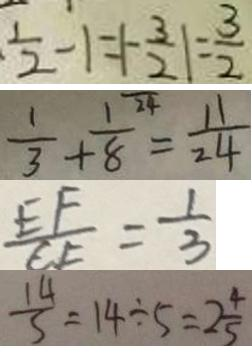Convert formula to latex. <formula><loc_0><loc_0><loc_500><loc_500>\frac { 1 } { 2 } - 1 = \vert - \frac { 3 } { 2 } \vert = \frac { 3 } { 2 } 
 \frac { 1 } { 3 } + \frac { 1 } { 8 } = \frac { 1 1 } { 2 4 } 
 \frac { E F } { C F } = \frac { 1 } { 3 } 
 \frac { 1 4 } { 5 } = 1 4 \div 5 = 2 \frac { 4 } { 5 }</formula> 